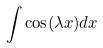Convert formula to latex. <formula><loc_0><loc_0><loc_500><loc_500>\int \cos ( \lambda x ) d x</formula> 